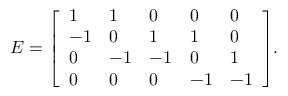Convert formula to latex. <formula><loc_0><loc_0><loc_500><loc_500>E = { \left [ \begin{array} { l l l l l } { 1 } & { 1 } & { 0 } & { 0 } & { 0 } \\ { - 1 } & { 0 } & { 1 } & { 1 } & { 0 } \\ { 0 } & { - 1 } & { - 1 } & { 0 } & { 1 } \\ { 0 } & { 0 } & { 0 } & { - 1 } & { - 1 } \end{array} \right ] } .</formula> 